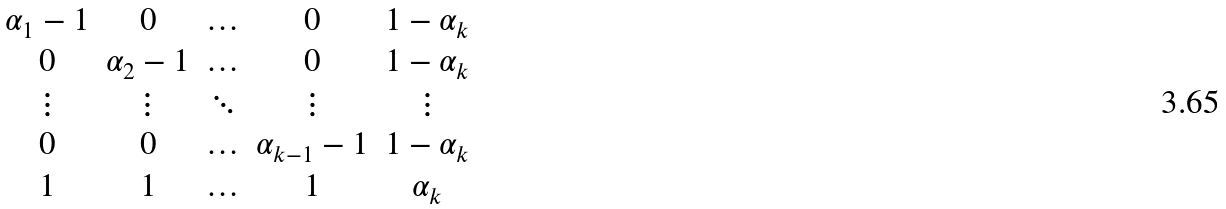Convert formula to latex. <formula><loc_0><loc_0><loc_500><loc_500>\begin{matrix} \alpha _ { 1 } - 1 & 0 & \hdots & 0 & 1 - \alpha _ { k } \\ 0 & \alpha _ { 2 } - 1 & \hdots & 0 & 1 - \alpha _ { k } \\ \vdots & \vdots & \ddots & \vdots & \vdots \\ 0 & 0 & \hdots & \alpha _ { k - 1 } - 1 & 1 - \alpha _ { k } \\ 1 & 1 & \hdots & 1 & \alpha _ { k } \end{matrix}</formula> 